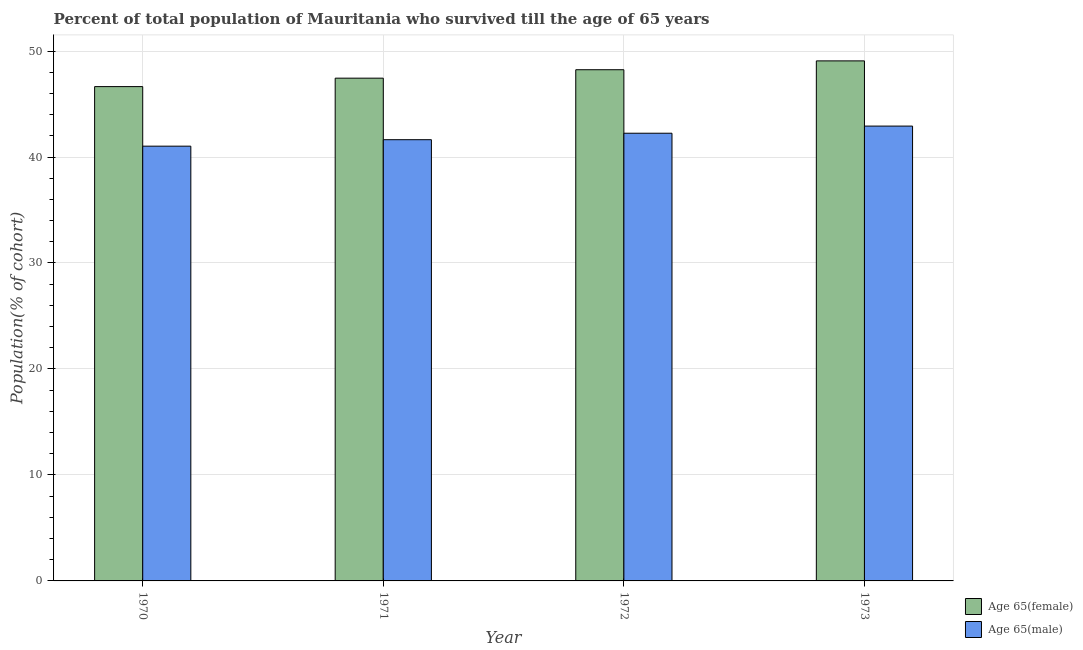Are the number of bars per tick equal to the number of legend labels?
Provide a succinct answer. Yes. How many bars are there on the 1st tick from the right?
Your response must be concise. 2. What is the label of the 4th group of bars from the left?
Your answer should be compact. 1973. In how many cases, is the number of bars for a given year not equal to the number of legend labels?
Your answer should be compact. 0. What is the percentage of male population who survived till age of 65 in 1971?
Your answer should be compact. 41.64. Across all years, what is the maximum percentage of male population who survived till age of 65?
Make the answer very short. 42.92. Across all years, what is the minimum percentage of female population who survived till age of 65?
Offer a terse response. 46.64. In which year was the percentage of female population who survived till age of 65 maximum?
Give a very brief answer. 1973. What is the total percentage of male population who survived till age of 65 in the graph?
Your response must be concise. 167.83. What is the difference between the percentage of male population who survived till age of 65 in 1970 and that in 1973?
Your answer should be very brief. -1.9. What is the difference between the percentage of female population who survived till age of 65 in 1972 and the percentage of male population who survived till age of 65 in 1973?
Offer a very short reply. -0.83. What is the average percentage of female population who survived till age of 65 per year?
Offer a terse response. 47.85. In the year 1972, what is the difference between the percentage of male population who survived till age of 65 and percentage of female population who survived till age of 65?
Make the answer very short. 0. What is the ratio of the percentage of male population who survived till age of 65 in 1971 to that in 1973?
Your answer should be very brief. 0.97. Is the percentage of male population who survived till age of 65 in 1971 less than that in 1972?
Offer a terse response. Yes. What is the difference between the highest and the second highest percentage of male population who survived till age of 65?
Offer a very short reply. 0.67. What is the difference between the highest and the lowest percentage of male population who survived till age of 65?
Your response must be concise. 1.9. Is the sum of the percentage of female population who survived till age of 65 in 1970 and 1973 greater than the maximum percentage of male population who survived till age of 65 across all years?
Offer a very short reply. Yes. What does the 1st bar from the left in 1970 represents?
Make the answer very short. Age 65(female). What does the 2nd bar from the right in 1973 represents?
Your answer should be very brief. Age 65(female). How many bars are there?
Make the answer very short. 8. What is the difference between two consecutive major ticks on the Y-axis?
Make the answer very short. 10. Are the values on the major ticks of Y-axis written in scientific E-notation?
Your response must be concise. No. Does the graph contain grids?
Provide a short and direct response. Yes. Where does the legend appear in the graph?
Make the answer very short. Bottom right. How are the legend labels stacked?
Ensure brevity in your answer.  Vertical. What is the title of the graph?
Give a very brief answer. Percent of total population of Mauritania who survived till the age of 65 years. Does "International Visitors" appear as one of the legend labels in the graph?
Your answer should be compact. No. What is the label or title of the X-axis?
Provide a succinct answer. Year. What is the label or title of the Y-axis?
Your response must be concise. Population(% of cohort). What is the Population(% of cohort) of Age 65(female) in 1970?
Offer a terse response. 46.64. What is the Population(% of cohort) of Age 65(male) in 1970?
Keep it short and to the point. 41.02. What is the Population(% of cohort) of Age 65(female) in 1971?
Provide a succinct answer. 47.44. What is the Population(% of cohort) in Age 65(male) in 1971?
Your response must be concise. 41.64. What is the Population(% of cohort) in Age 65(female) in 1972?
Your response must be concise. 48.24. What is the Population(% of cohort) in Age 65(male) in 1972?
Ensure brevity in your answer.  42.25. What is the Population(% of cohort) of Age 65(female) in 1973?
Ensure brevity in your answer.  49.07. What is the Population(% of cohort) in Age 65(male) in 1973?
Offer a terse response. 42.92. Across all years, what is the maximum Population(% of cohort) of Age 65(female)?
Provide a succinct answer. 49.07. Across all years, what is the maximum Population(% of cohort) in Age 65(male)?
Offer a terse response. 42.92. Across all years, what is the minimum Population(% of cohort) of Age 65(female)?
Your answer should be compact. 46.64. Across all years, what is the minimum Population(% of cohort) in Age 65(male)?
Give a very brief answer. 41.02. What is the total Population(% of cohort) in Age 65(female) in the graph?
Offer a very short reply. 191.4. What is the total Population(% of cohort) of Age 65(male) in the graph?
Ensure brevity in your answer.  167.83. What is the difference between the Population(% of cohort) of Age 65(female) in 1970 and that in 1971?
Give a very brief answer. -0.8. What is the difference between the Population(% of cohort) of Age 65(male) in 1970 and that in 1971?
Offer a terse response. -0.61. What is the difference between the Population(% of cohort) in Age 65(female) in 1970 and that in 1972?
Your response must be concise. -1.59. What is the difference between the Population(% of cohort) of Age 65(male) in 1970 and that in 1972?
Your answer should be very brief. -1.22. What is the difference between the Population(% of cohort) in Age 65(female) in 1970 and that in 1973?
Keep it short and to the point. -2.43. What is the difference between the Population(% of cohort) in Age 65(male) in 1970 and that in 1973?
Offer a very short reply. -1.9. What is the difference between the Population(% of cohort) of Age 65(female) in 1971 and that in 1972?
Provide a succinct answer. -0.8. What is the difference between the Population(% of cohort) in Age 65(male) in 1971 and that in 1972?
Your response must be concise. -0.61. What is the difference between the Population(% of cohort) in Age 65(female) in 1971 and that in 1973?
Make the answer very short. -1.63. What is the difference between the Population(% of cohort) in Age 65(male) in 1971 and that in 1973?
Your answer should be compact. -1.28. What is the difference between the Population(% of cohort) of Age 65(female) in 1972 and that in 1973?
Provide a succinct answer. -0.83. What is the difference between the Population(% of cohort) in Age 65(male) in 1972 and that in 1973?
Make the answer very short. -0.67. What is the difference between the Population(% of cohort) in Age 65(female) in 1970 and the Population(% of cohort) in Age 65(male) in 1971?
Provide a succinct answer. 5.01. What is the difference between the Population(% of cohort) of Age 65(female) in 1970 and the Population(% of cohort) of Age 65(male) in 1972?
Your answer should be very brief. 4.4. What is the difference between the Population(% of cohort) of Age 65(female) in 1970 and the Population(% of cohort) of Age 65(male) in 1973?
Keep it short and to the point. 3.72. What is the difference between the Population(% of cohort) in Age 65(female) in 1971 and the Population(% of cohort) in Age 65(male) in 1972?
Make the answer very short. 5.2. What is the difference between the Population(% of cohort) in Age 65(female) in 1971 and the Population(% of cohort) in Age 65(male) in 1973?
Provide a short and direct response. 4.52. What is the difference between the Population(% of cohort) of Age 65(female) in 1972 and the Population(% of cohort) of Age 65(male) in 1973?
Provide a succinct answer. 5.32. What is the average Population(% of cohort) of Age 65(female) per year?
Your answer should be very brief. 47.85. What is the average Population(% of cohort) of Age 65(male) per year?
Make the answer very short. 41.96. In the year 1970, what is the difference between the Population(% of cohort) in Age 65(female) and Population(% of cohort) in Age 65(male)?
Make the answer very short. 5.62. In the year 1971, what is the difference between the Population(% of cohort) in Age 65(female) and Population(% of cohort) in Age 65(male)?
Provide a succinct answer. 5.81. In the year 1972, what is the difference between the Population(% of cohort) of Age 65(female) and Population(% of cohort) of Age 65(male)?
Your answer should be compact. 5.99. In the year 1973, what is the difference between the Population(% of cohort) of Age 65(female) and Population(% of cohort) of Age 65(male)?
Ensure brevity in your answer.  6.15. What is the ratio of the Population(% of cohort) in Age 65(female) in 1970 to that in 1971?
Provide a short and direct response. 0.98. What is the ratio of the Population(% of cohort) of Age 65(male) in 1970 to that in 1971?
Provide a short and direct response. 0.99. What is the ratio of the Population(% of cohort) in Age 65(male) in 1970 to that in 1972?
Provide a short and direct response. 0.97. What is the ratio of the Population(% of cohort) in Age 65(female) in 1970 to that in 1973?
Provide a short and direct response. 0.95. What is the ratio of the Population(% of cohort) in Age 65(male) in 1970 to that in 1973?
Ensure brevity in your answer.  0.96. What is the ratio of the Population(% of cohort) of Age 65(female) in 1971 to that in 1972?
Provide a short and direct response. 0.98. What is the ratio of the Population(% of cohort) in Age 65(male) in 1971 to that in 1972?
Provide a short and direct response. 0.99. What is the ratio of the Population(% of cohort) in Age 65(female) in 1971 to that in 1973?
Your answer should be very brief. 0.97. What is the ratio of the Population(% of cohort) in Age 65(male) in 1971 to that in 1973?
Keep it short and to the point. 0.97. What is the ratio of the Population(% of cohort) of Age 65(female) in 1972 to that in 1973?
Your answer should be very brief. 0.98. What is the ratio of the Population(% of cohort) in Age 65(male) in 1972 to that in 1973?
Offer a very short reply. 0.98. What is the difference between the highest and the second highest Population(% of cohort) of Age 65(female)?
Ensure brevity in your answer.  0.83. What is the difference between the highest and the second highest Population(% of cohort) of Age 65(male)?
Your answer should be compact. 0.67. What is the difference between the highest and the lowest Population(% of cohort) of Age 65(female)?
Provide a succinct answer. 2.43. What is the difference between the highest and the lowest Population(% of cohort) in Age 65(male)?
Offer a terse response. 1.9. 